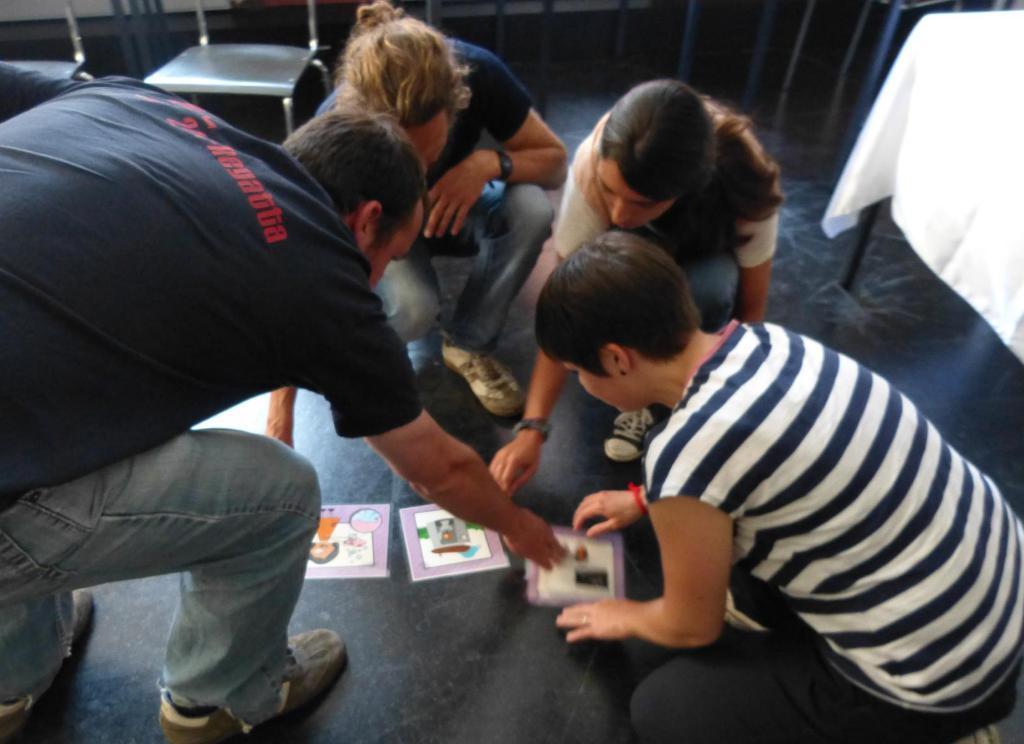In one or two sentences, can you explain what this image depicts? In this image I can see four persons and I can also see few papers on the floor. In the background I can see few chairs and the table. 